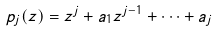<formula> <loc_0><loc_0><loc_500><loc_500>p _ { j } ( z ) = z ^ { j } + a _ { 1 } z ^ { j - 1 } + { \cdots } + a _ { j }</formula> 